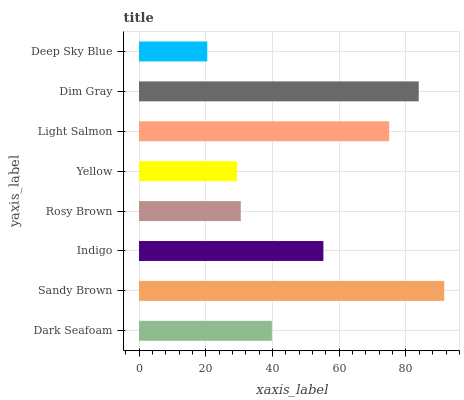Is Deep Sky Blue the minimum?
Answer yes or no. Yes. Is Sandy Brown the maximum?
Answer yes or no. Yes. Is Indigo the minimum?
Answer yes or no. No. Is Indigo the maximum?
Answer yes or no. No. Is Sandy Brown greater than Indigo?
Answer yes or no. Yes. Is Indigo less than Sandy Brown?
Answer yes or no. Yes. Is Indigo greater than Sandy Brown?
Answer yes or no. No. Is Sandy Brown less than Indigo?
Answer yes or no. No. Is Indigo the high median?
Answer yes or no. Yes. Is Dark Seafoam the low median?
Answer yes or no. Yes. Is Deep Sky Blue the high median?
Answer yes or no. No. Is Yellow the low median?
Answer yes or no. No. 